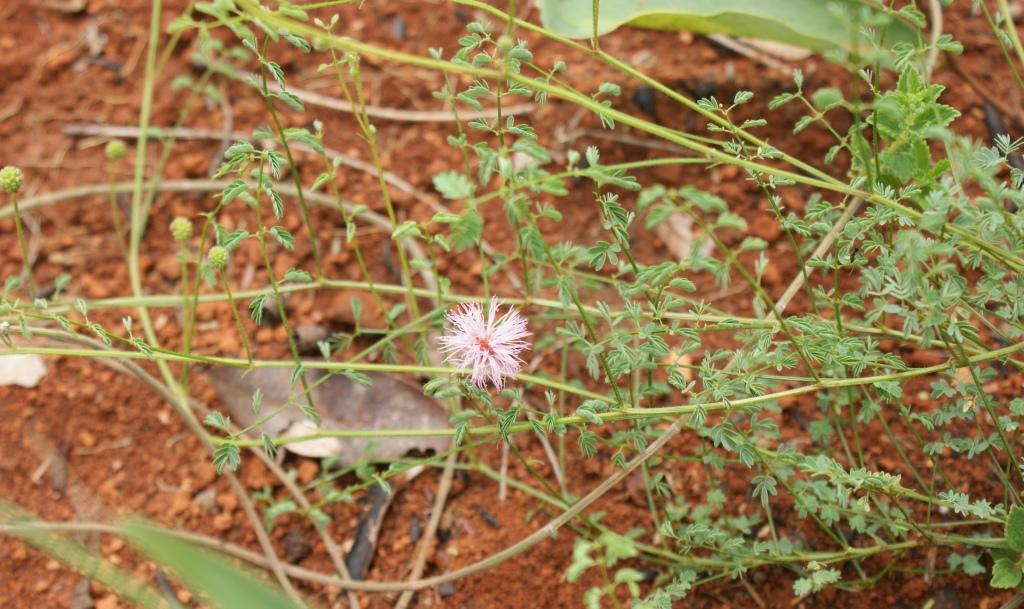What type of living organisms can be seen in the image? There are flowers and plants visible in the image. What is the primary setting of the image? The image features the ground as the background. What can be seen in the background of the image? There are objects and dry leaves visible in the background. What type of truck can be seen driving through the flowers in the image? There is no truck present in the image; it features flowers and plants without any vehicles. 